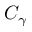<formula> <loc_0><loc_0><loc_500><loc_500>C _ { \gamma }</formula> 